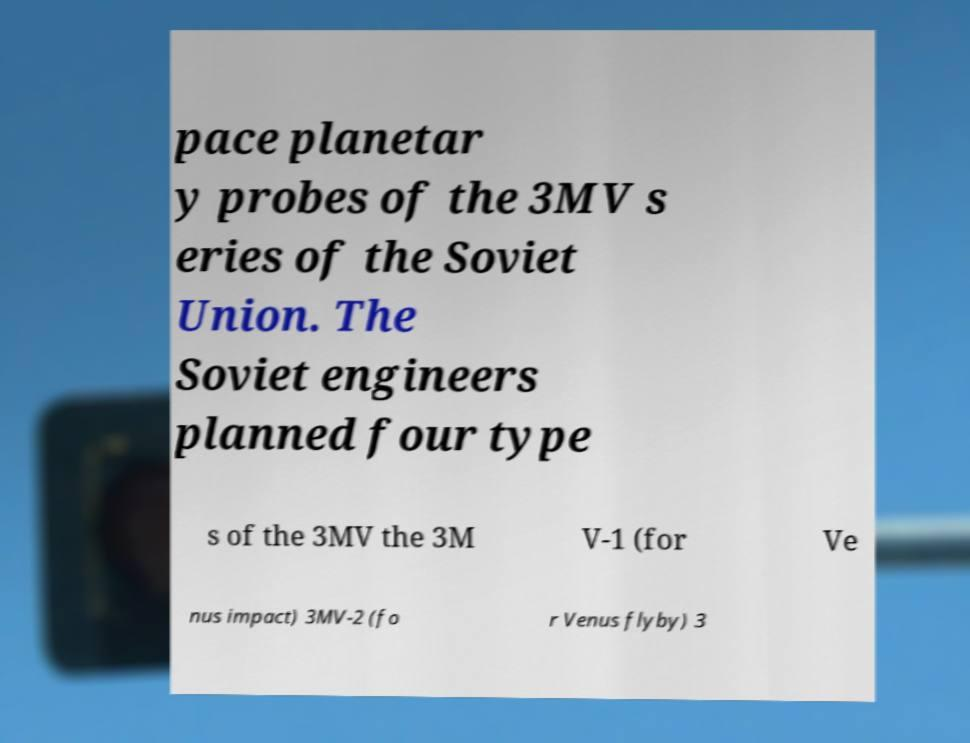What messages or text are displayed in this image? I need them in a readable, typed format. pace planetar y probes of the 3MV s eries of the Soviet Union. The Soviet engineers planned four type s of the 3MV the 3M V-1 (for Ve nus impact) 3MV-2 (fo r Venus flyby) 3 